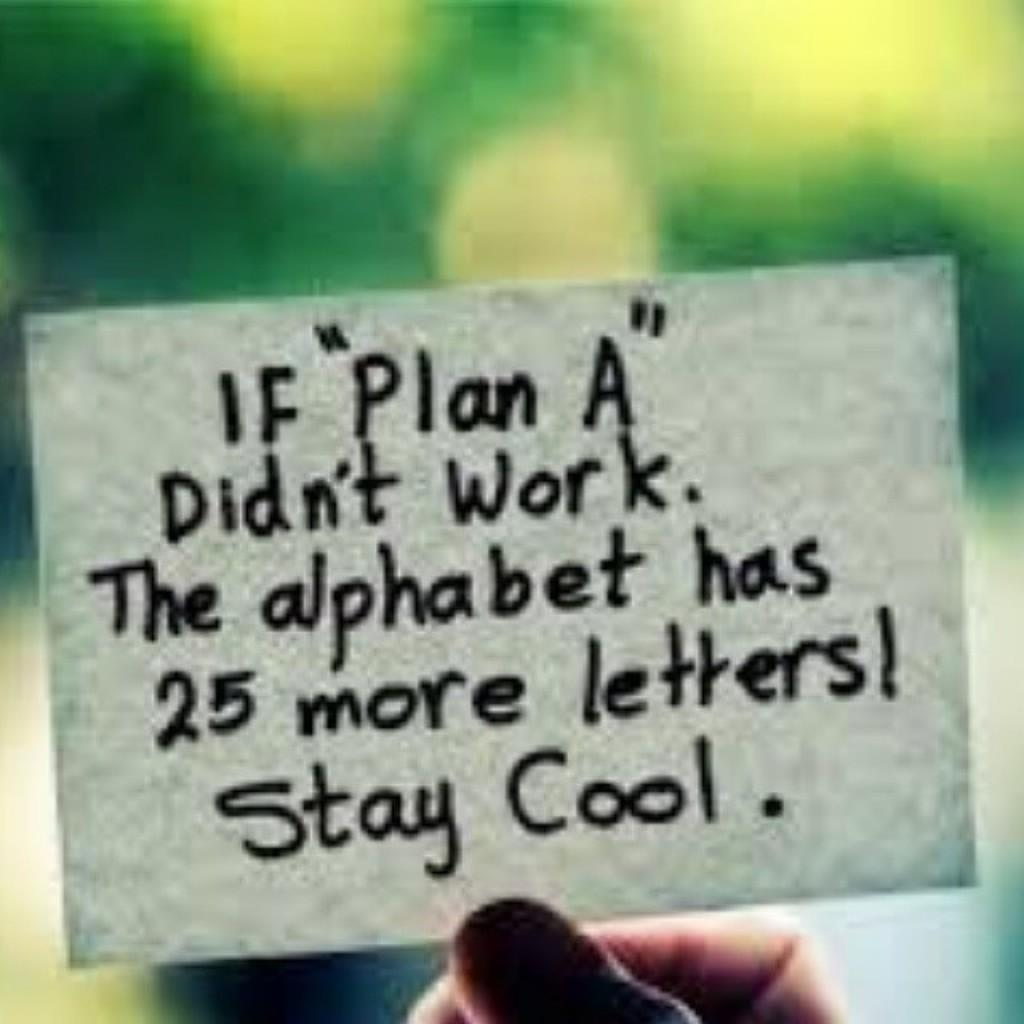What is being held in the person's hand in the image? There is a person's hand holding a card in the image. What can be seen on the card? The card has text on it. How would you describe the background of the image? The background of the image is blurred. Is the person wearing a veil in the image? There is no mention of a veil or any other clothing in the image; it only shows a person's hand holding a card with text on it. 